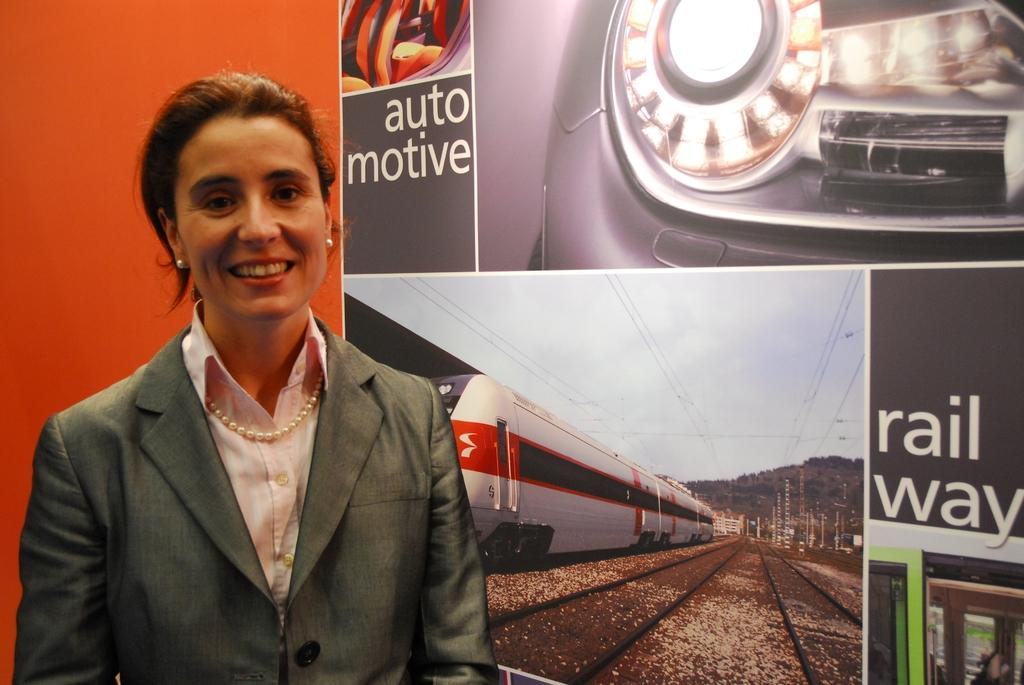Who is the main subject in the image? There is a lady in the image. What is the lady doing in the image? The lady is standing in the image. What expression does the lady have in the image? The lady is smiling in the image. What is the lady wearing in the image? The lady is wearing a suit in the image. What can be seen in the background of the image? There is a board in the background of the image. What type of thumb is the lady holding in the image? There is no thumb present in the image. Where is the hospital located in the image? There is no hospital present in the image. 